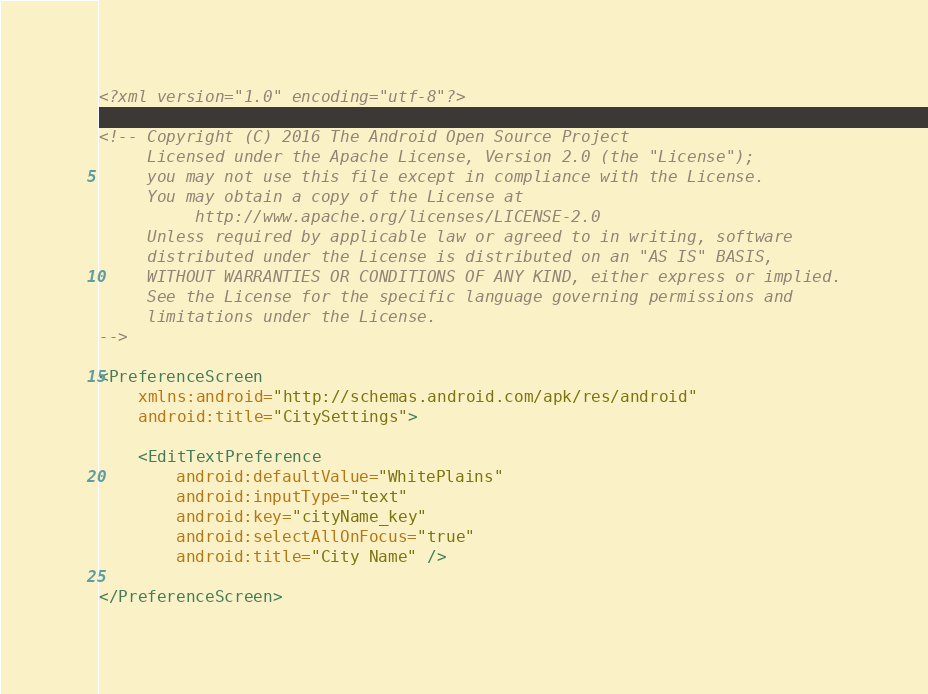Convert code to text. <code><loc_0><loc_0><loc_500><loc_500><_XML_><?xml version="1.0" encoding="utf-8"?>

<!-- Copyright (C) 2016 The Android Open Source Project
     Licensed under the Apache License, Version 2.0 (the "License");
     you may not use this file except in compliance with the License.
     You may obtain a copy of the License at
          http://www.apache.org/licenses/LICENSE-2.0
     Unless required by applicable law or agreed to in writing, software
     distributed under the License is distributed on an "AS IS" BASIS,
     WITHOUT WARRANTIES OR CONDITIONS OF ANY KIND, either express or implied.
     See the License for the specific language governing permissions and
     limitations under the License.
-->

<PreferenceScreen
    xmlns:android="http://schemas.android.com/apk/res/android"
    android:title="CitySettings">

    <EditTextPreference
        android:defaultValue="WhitePlains"
        android:inputType="text"
        android:key="cityName_key"
        android:selectAllOnFocus="true"
        android:title="City Name" />

</PreferenceScreen></code> 